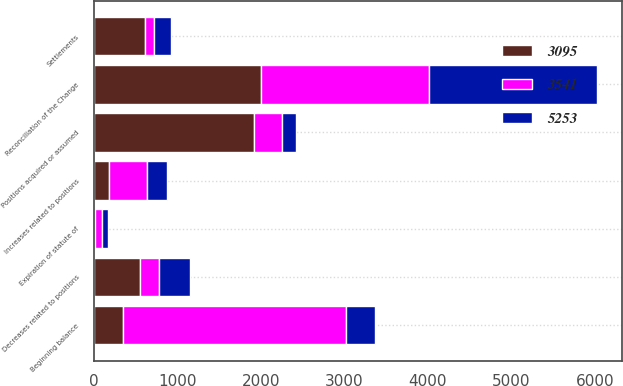Convert chart to OTSL. <chart><loc_0><loc_0><loc_500><loc_500><stacked_bar_chart><ecel><fcel>Reconciliation of the Change<fcel>Beginning balance<fcel>Increases related to positions<fcel>Positions acquired or assumed<fcel>Decreases related to positions<fcel>Settlements<fcel>Expiration of statute of<nl><fcel>3095<fcel>2009<fcel>349.5<fcel>181<fcel>1924<fcel>554<fcel>615<fcel>15<nl><fcel>5253<fcel>2008<fcel>349.5<fcel>241<fcel>169<fcel>371<fcel>209<fcel>72<nl><fcel>3541<fcel>2007<fcel>2667<fcel>456<fcel>328<fcel>227<fcel>108<fcel>88<nl></chart> 